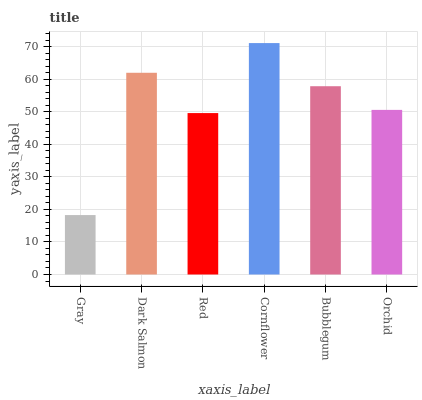Is Dark Salmon the minimum?
Answer yes or no. No. Is Dark Salmon the maximum?
Answer yes or no. No. Is Dark Salmon greater than Gray?
Answer yes or no. Yes. Is Gray less than Dark Salmon?
Answer yes or no. Yes. Is Gray greater than Dark Salmon?
Answer yes or no. No. Is Dark Salmon less than Gray?
Answer yes or no. No. Is Bubblegum the high median?
Answer yes or no. Yes. Is Orchid the low median?
Answer yes or no. Yes. Is Gray the high median?
Answer yes or no. No. Is Bubblegum the low median?
Answer yes or no. No. 